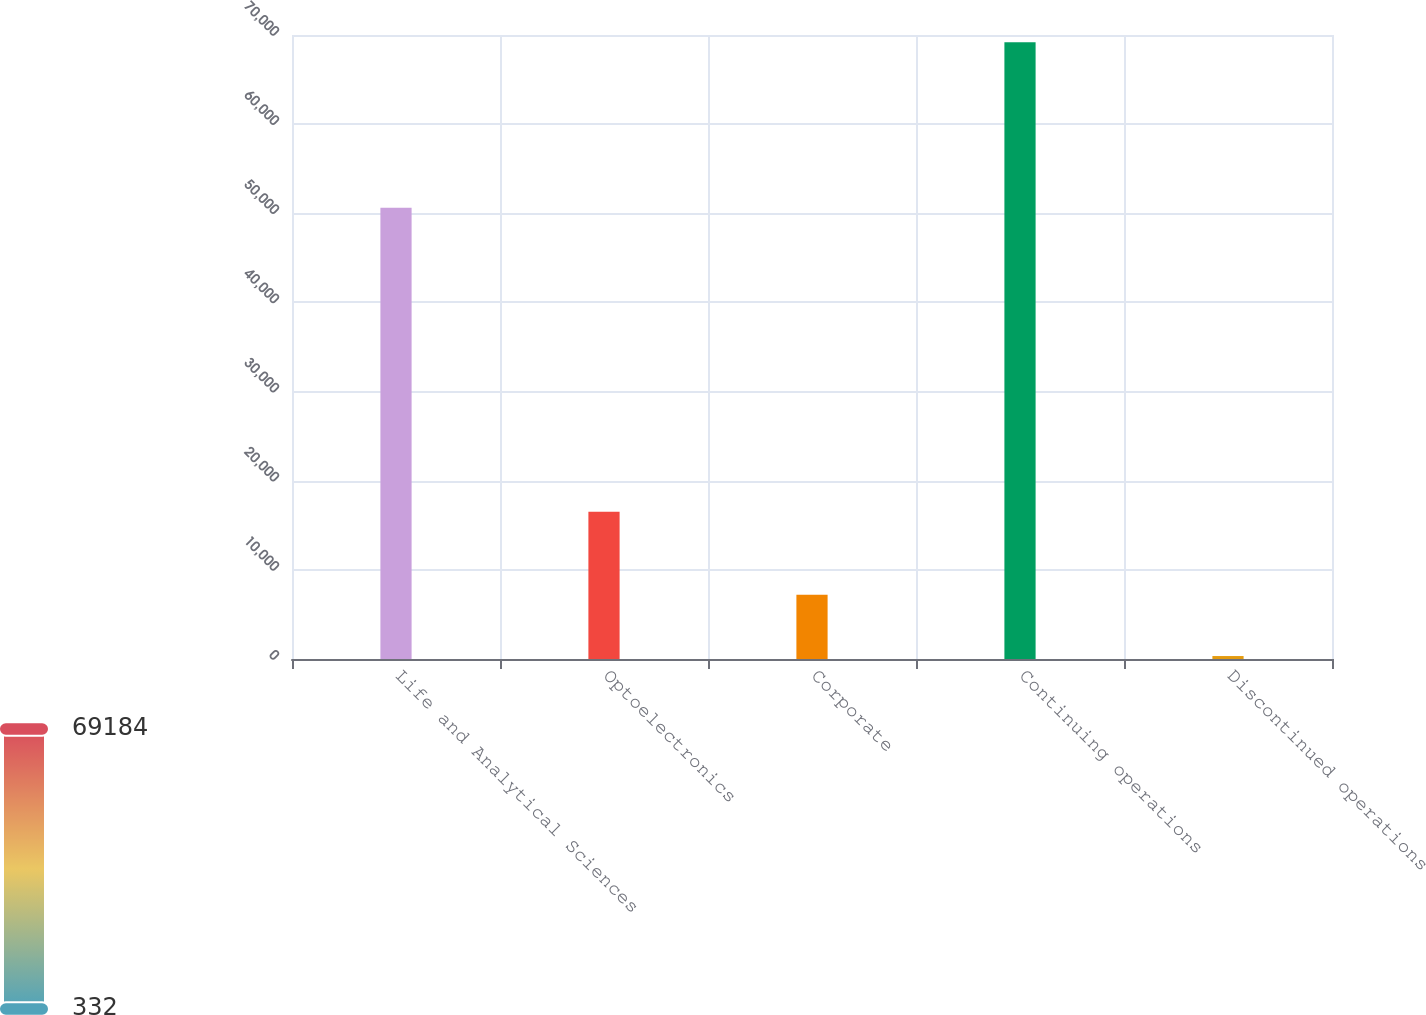Convert chart to OTSL. <chart><loc_0><loc_0><loc_500><loc_500><bar_chart><fcel>Life and Analytical Sciences<fcel>Optoelectronics<fcel>Corporate<fcel>Continuing operations<fcel>Discontinued operations<nl><fcel>50613<fcel>16522<fcel>7217.2<fcel>69184<fcel>332<nl></chart> 